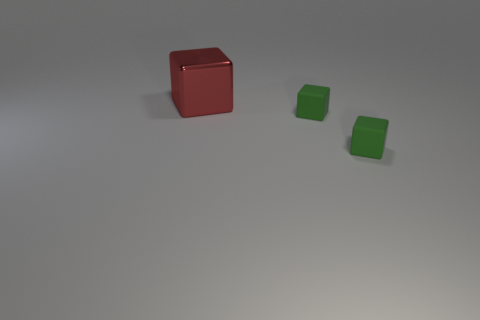Are there any large red blocks behind the big red metallic thing?
Make the answer very short. No. Is there another metallic thing of the same shape as the red metallic object?
Offer a terse response. No. Is the number of red metal things greater than the number of rubber spheres?
Offer a terse response. Yes. What number of cubes have the same color as the large object?
Offer a terse response. 0. How many blocks are either small things or big red things?
Your answer should be compact. 3. What size is the red thing?
Keep it short and to the point. Large. What number of things are either green matte objects or big metal objects?
Give a very brief answer. 3. What number of objects are either objects that are in front of the red metal cube or blocks that are right of the big red object?
Ensure brevity in your answer.  2. Is there anything else that is the same shape as the metal thing?
Your answer should be very brief. Yes. What is the material of the big cube?
Provide a succinct answer. Metal. 